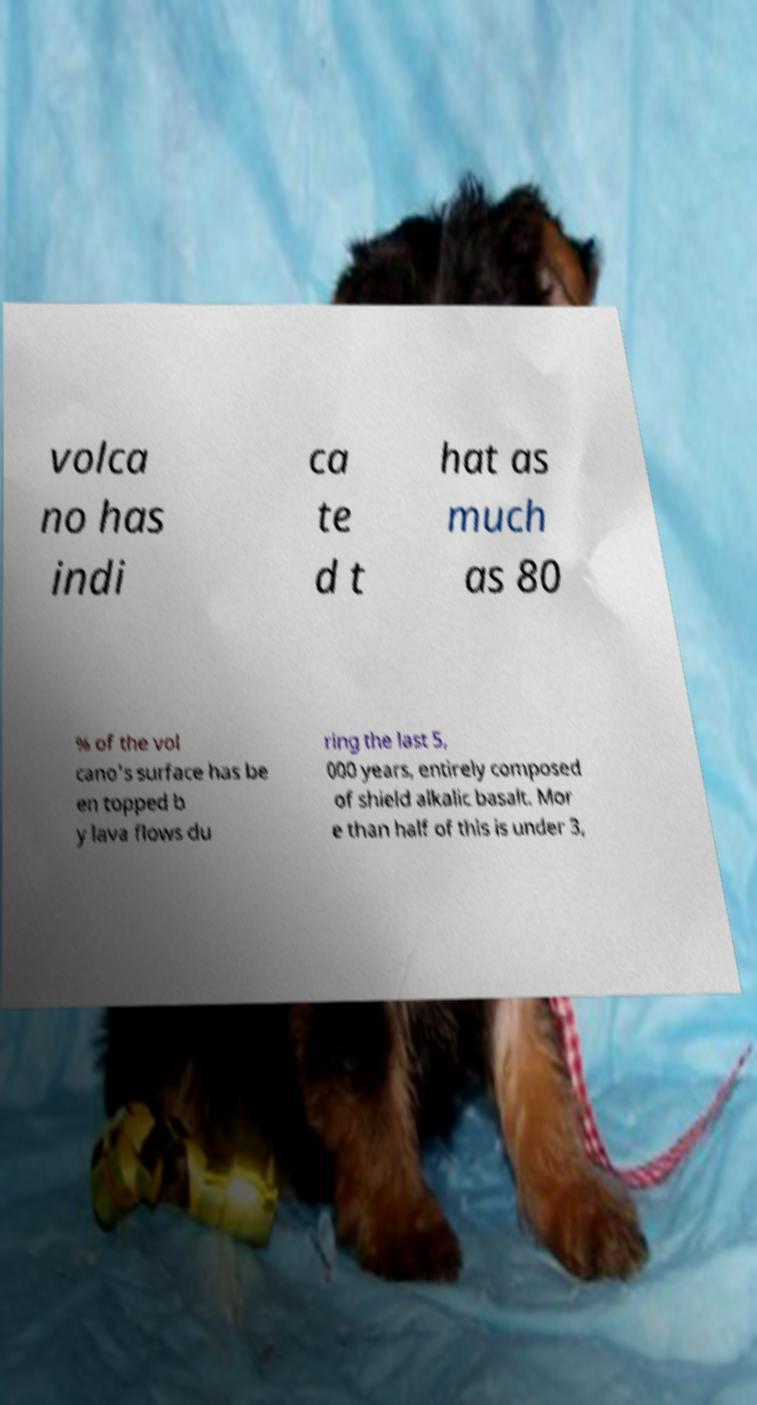Please identify and transcribe the text found in this image. volca no has indi ca te d t hat as much as 80 % of the vol cano's surface has be en topped b y lava flows du ring the last 5, 000 years, entirely composed of shield alkalic basalt. Mor e than half of this is under 3, 